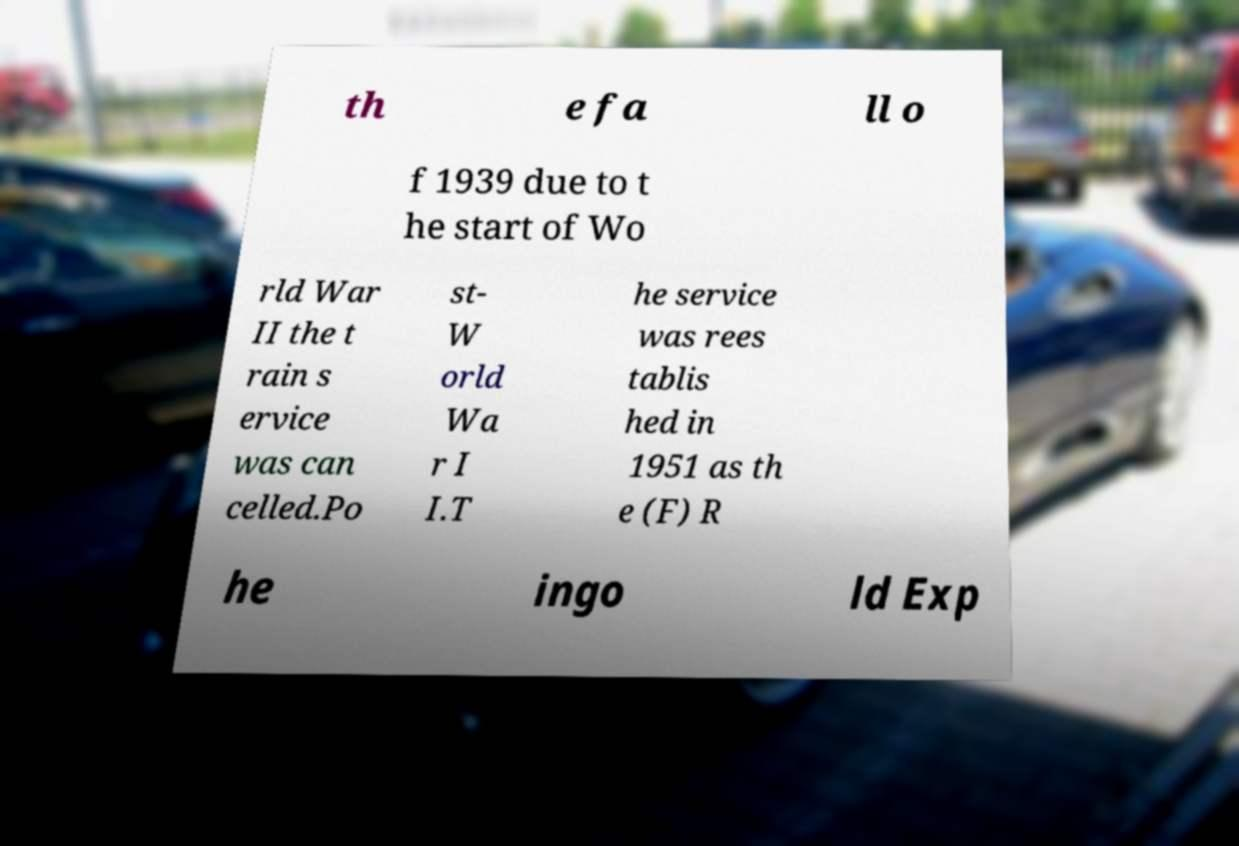Please read and relay the text visible in this image. What does it say? th e fa ll o f 1939 due to t he start of Wo rld War II the t rain s ervice was can celled.Po st- W orld Wa r I I.T he service was rees tablis hed in 1951 as th e (F) R he ingo ld Exp 